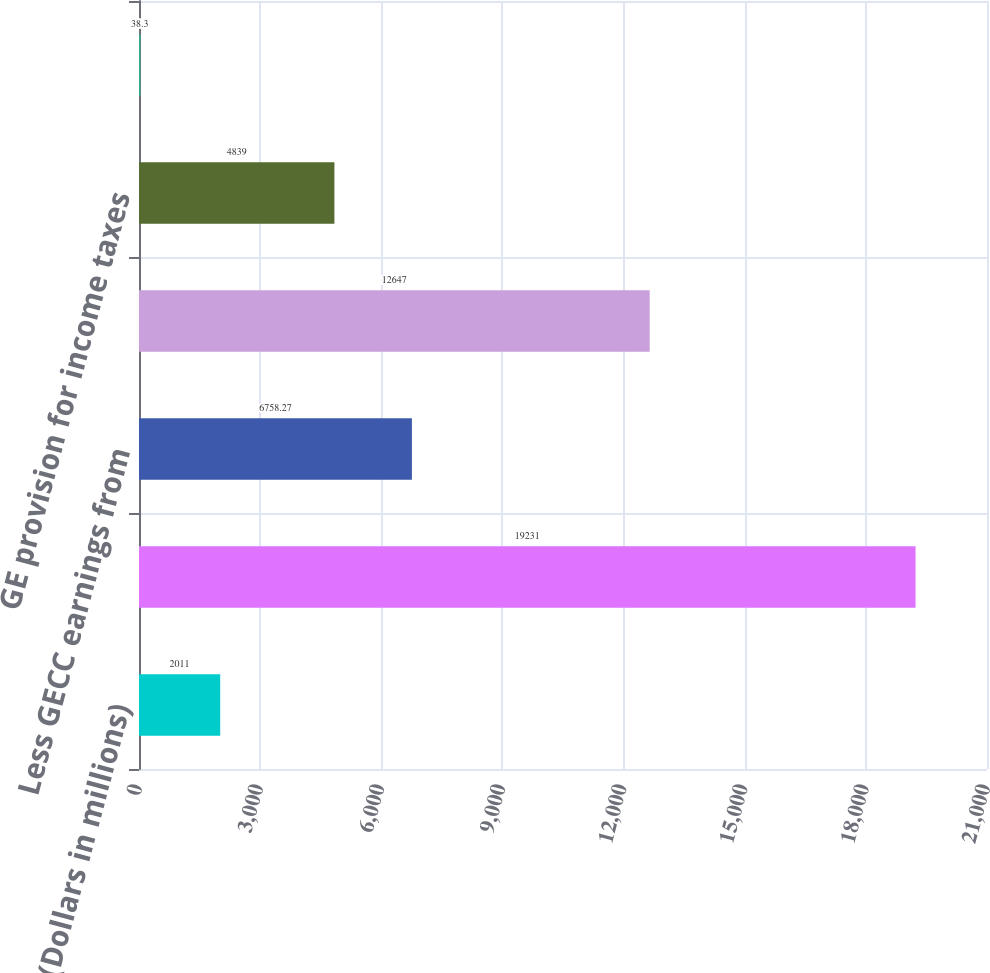<chart> <loc_0><loc_0><loc_500><loc_500><bar_chart><fcel>(Dollars in millions)<fcel>GE earnings from continuing<fcel>Less GECC earnings from<fcel>Total<fcel>GE provision for income taxes<fcel>GE effective tax rate<nl><fcel>2011<fcel>19231<fcel>6758.27<fcel>12647<fcel>4839<fcel>38.3<nl></chart> 